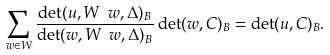<formula> <loc_0><loc_0><loc_500><loc_500>\sum _ { w \in W } \frac { \det ( u , W \ w , \Delta ) _ { B } } { \det ( w , W \ w , \Delta ) _ { B } } \det ( w , C ) _ { B } = \det ( u , C ) _ { B } .</formula> 